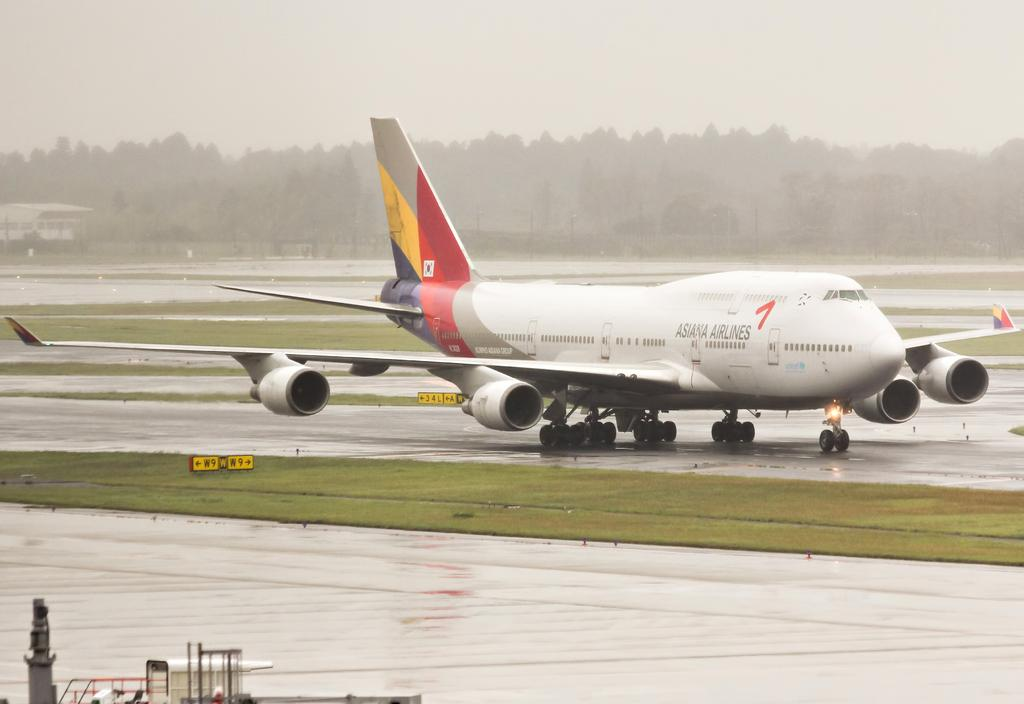<image>
Relay a brief, clear account of the picture shown. A giant plane on the runway owned by Asiana Airlines 